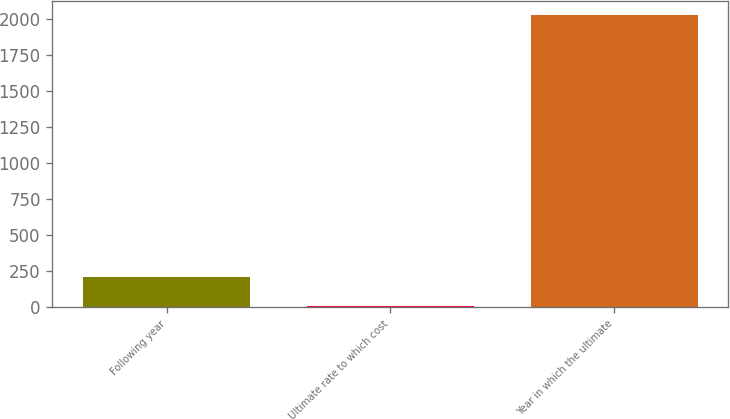Convert chart to OTSL. <chart><loc_0><loc_0><loc_500><loc_500><bar_chart><fcel>Following year<fcel>Ultimate rate to which cost<fcel>Year in which the ultimate<nl><fcel>206.8<fcel>5<fcel>2023<nl></chart> 